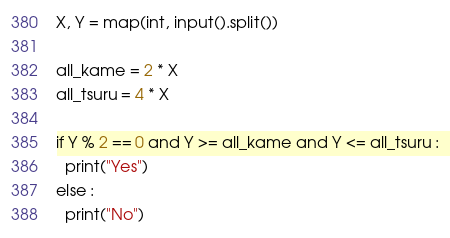Convert code to text. <code><loc_0><loc_0><loc_500><loc_500><_Python_>X, Y = map(int, input().split())

all_kame = 2 * X
all_tsuru = 4 * X

if Y % 2 == 0 and Y >= all_kame and Y <= all_tsuru :
  print("Yes")
else :
  print("No")</code> 